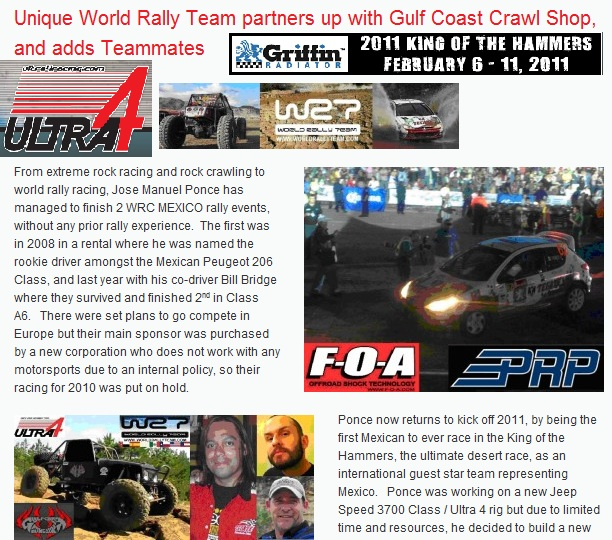What might be the implications for sponsors like Gulf Coast Crawl Shop in supporting events like WRC Mexico and the King of the Hammers? Sponsors like the Gulf Coast Crawl Shop likely gain significant benefits from supporting events like WRC Mexico and the King of the Hammers. These events provide high visibility ranging from extensive media coverage to large live audiences, boosting brand recognition. Associating their brand with successful teams and skilled drivers like Jose Manuel Ponce and Bill Bridge also aligns their image with expertise and excellence in motorsports. Furthermore, such sponsorships can strengthen relationships within the racing community and potentially increase sales as fans and participants seek out the sponsors’ products. 